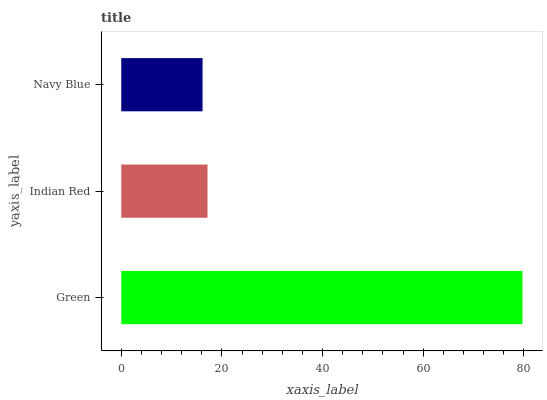Is Navy Blue the minimum?
Answer yes or no. Yes. Is Green the maximum?
Answer yes or no. Yes. Is Indian Red the minimum?
Answer yes or no. No. Is Indian Red the maximum?
Answer yes or no. No. Is Green greater than Indian Red?
Answer yes or no. Yes. Is Indian Red less than Green?
Answer yes or no. Yes. Is Indian Red greater than Green?
Answer yes or no. No. Is Green less than Indian Red?
Answer yes or no. No. Is Indian Red the high median?
Answer yes or no. Yes. Is Indian Red the low median?
Answer yes or no. Yes. Is Navy Blue the high median?
Answer yes or no. No. Is Green the low median?
Answer yes or no. No. 